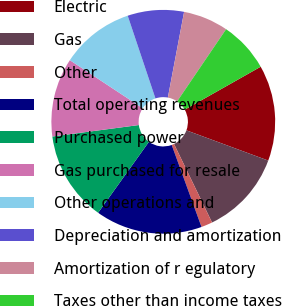Convert chart. <chart><loc_0><loc_0><loc_500><loc_500><pie_chart><fcel>Electric<fcel>Gas<fcel>Other<fcel>Total operating revenues<fcel>Purchased power<fcel>Gas purchased for resale<fcel>Other operations and<fcel>Depreciation and amortization<fcel>Amortization of r egulatory<fcel>Taxes other than income taxes<nl><fcel>13.82%<fcel>12.19%<fcel>1.63%<fcel>15.44%<fcel>13.01%<fcel>11.38%<fcel>10.57%<fcel>8.13%<fcel>6.51%<fcel>7.32%<nl></chart> 